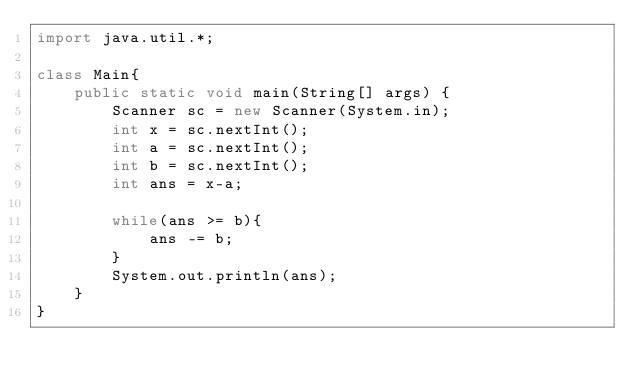Convert code to text. <code><loc_0><loc_0><loc_500><loc_500><_Java_>import java.util.*;

class Main{
    public static void main(String[] args) {
        Scanner sc = new Scanner(System.in);
        int x = sc.nextInt();
        int a = sc.nextInt();
        int b = sc.nextInt();
        int ans = x-a;

        while(ans >= b){
            ans -= b;
        }
        System.out.println(ans);
    }
}</code> 